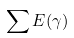<formula> <loc_0><loc_0><loc_500><loc_500>\sum E ( \gamma )</formula> 